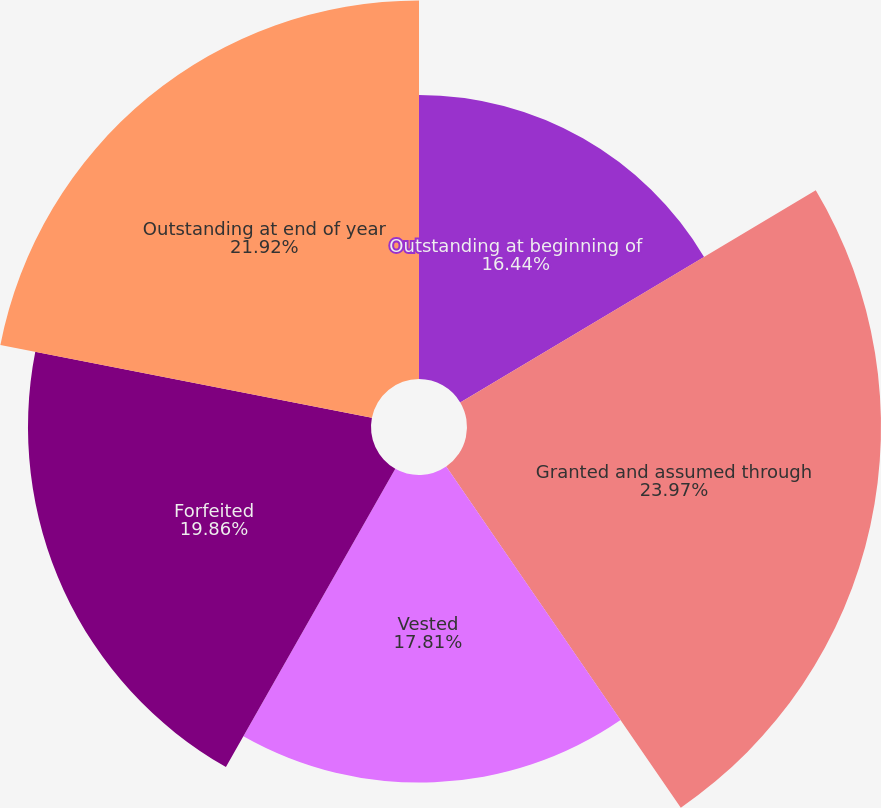Convert chart to OTSL. <chart><loc_0><loc_0><loc_500><loc_500><pie_chart><fcel>Outstanding at beginning of<fcel>Granted and assumed through<fcel>Vested<fcel>Forfeited<fcel>Outstanding at end of year<nl><fcel>16.44%<fcel>23.97%<fcel>17.81%<fcel>19.86%<fcel>21.92%<nl></chart> 